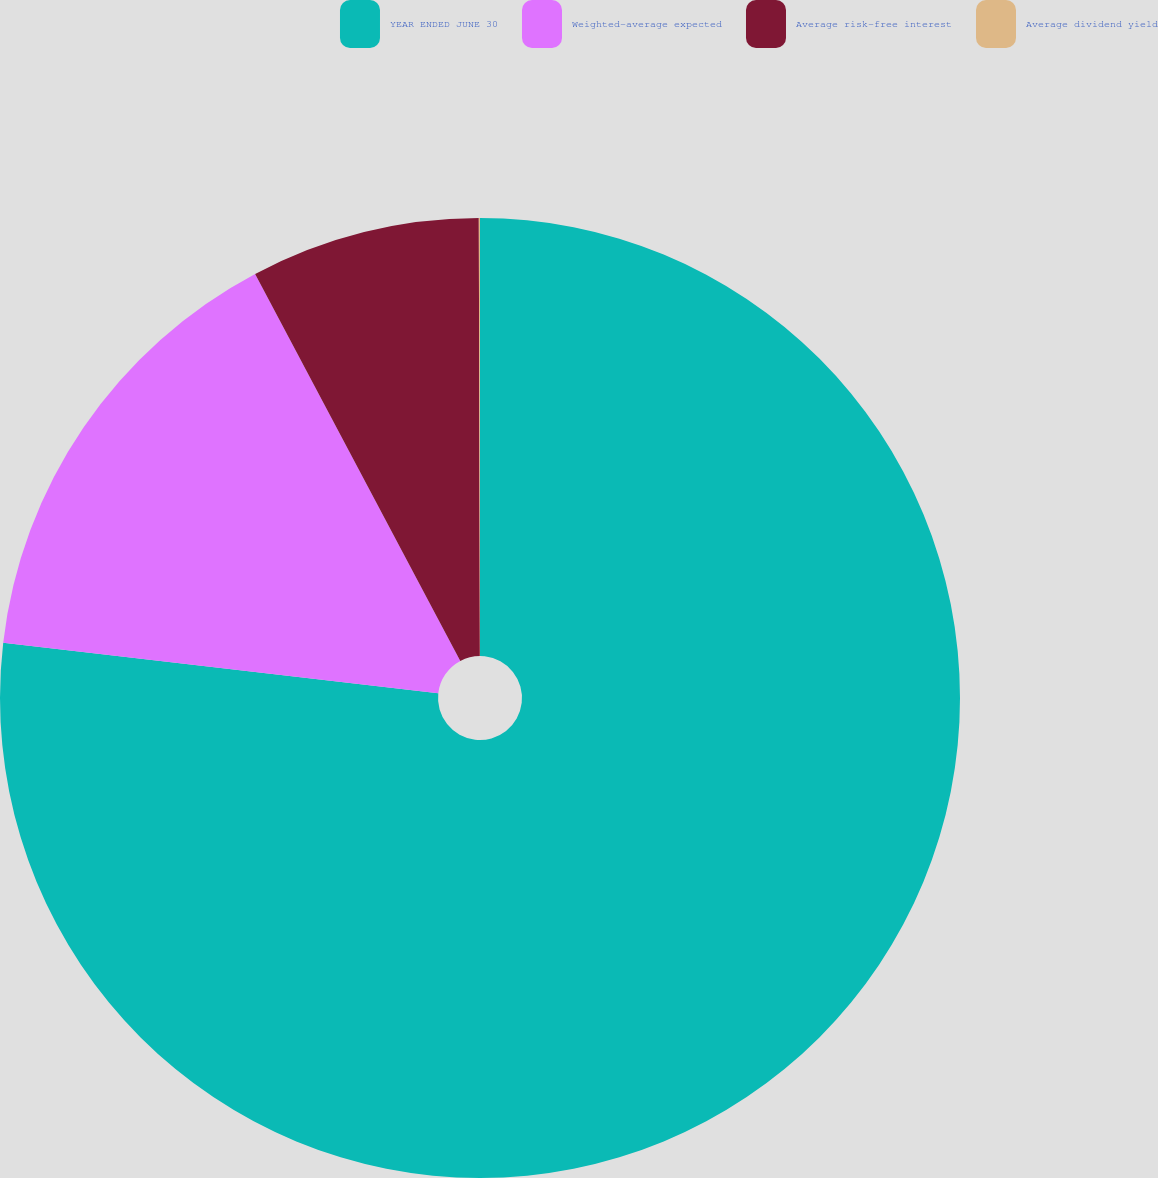<chart> <loc_0><loc_0><loc_500><loc_500><pie_chart><fcel>YEAR ENDED JUNE 30<fcel>Weighted-average expected<fcel>Average risk-free interest<fcel>Average dividend yield<nl><fcel>76.84%<fcel>15.4%<fcel>7.72%<fcel>0.04%<nl></chart> 